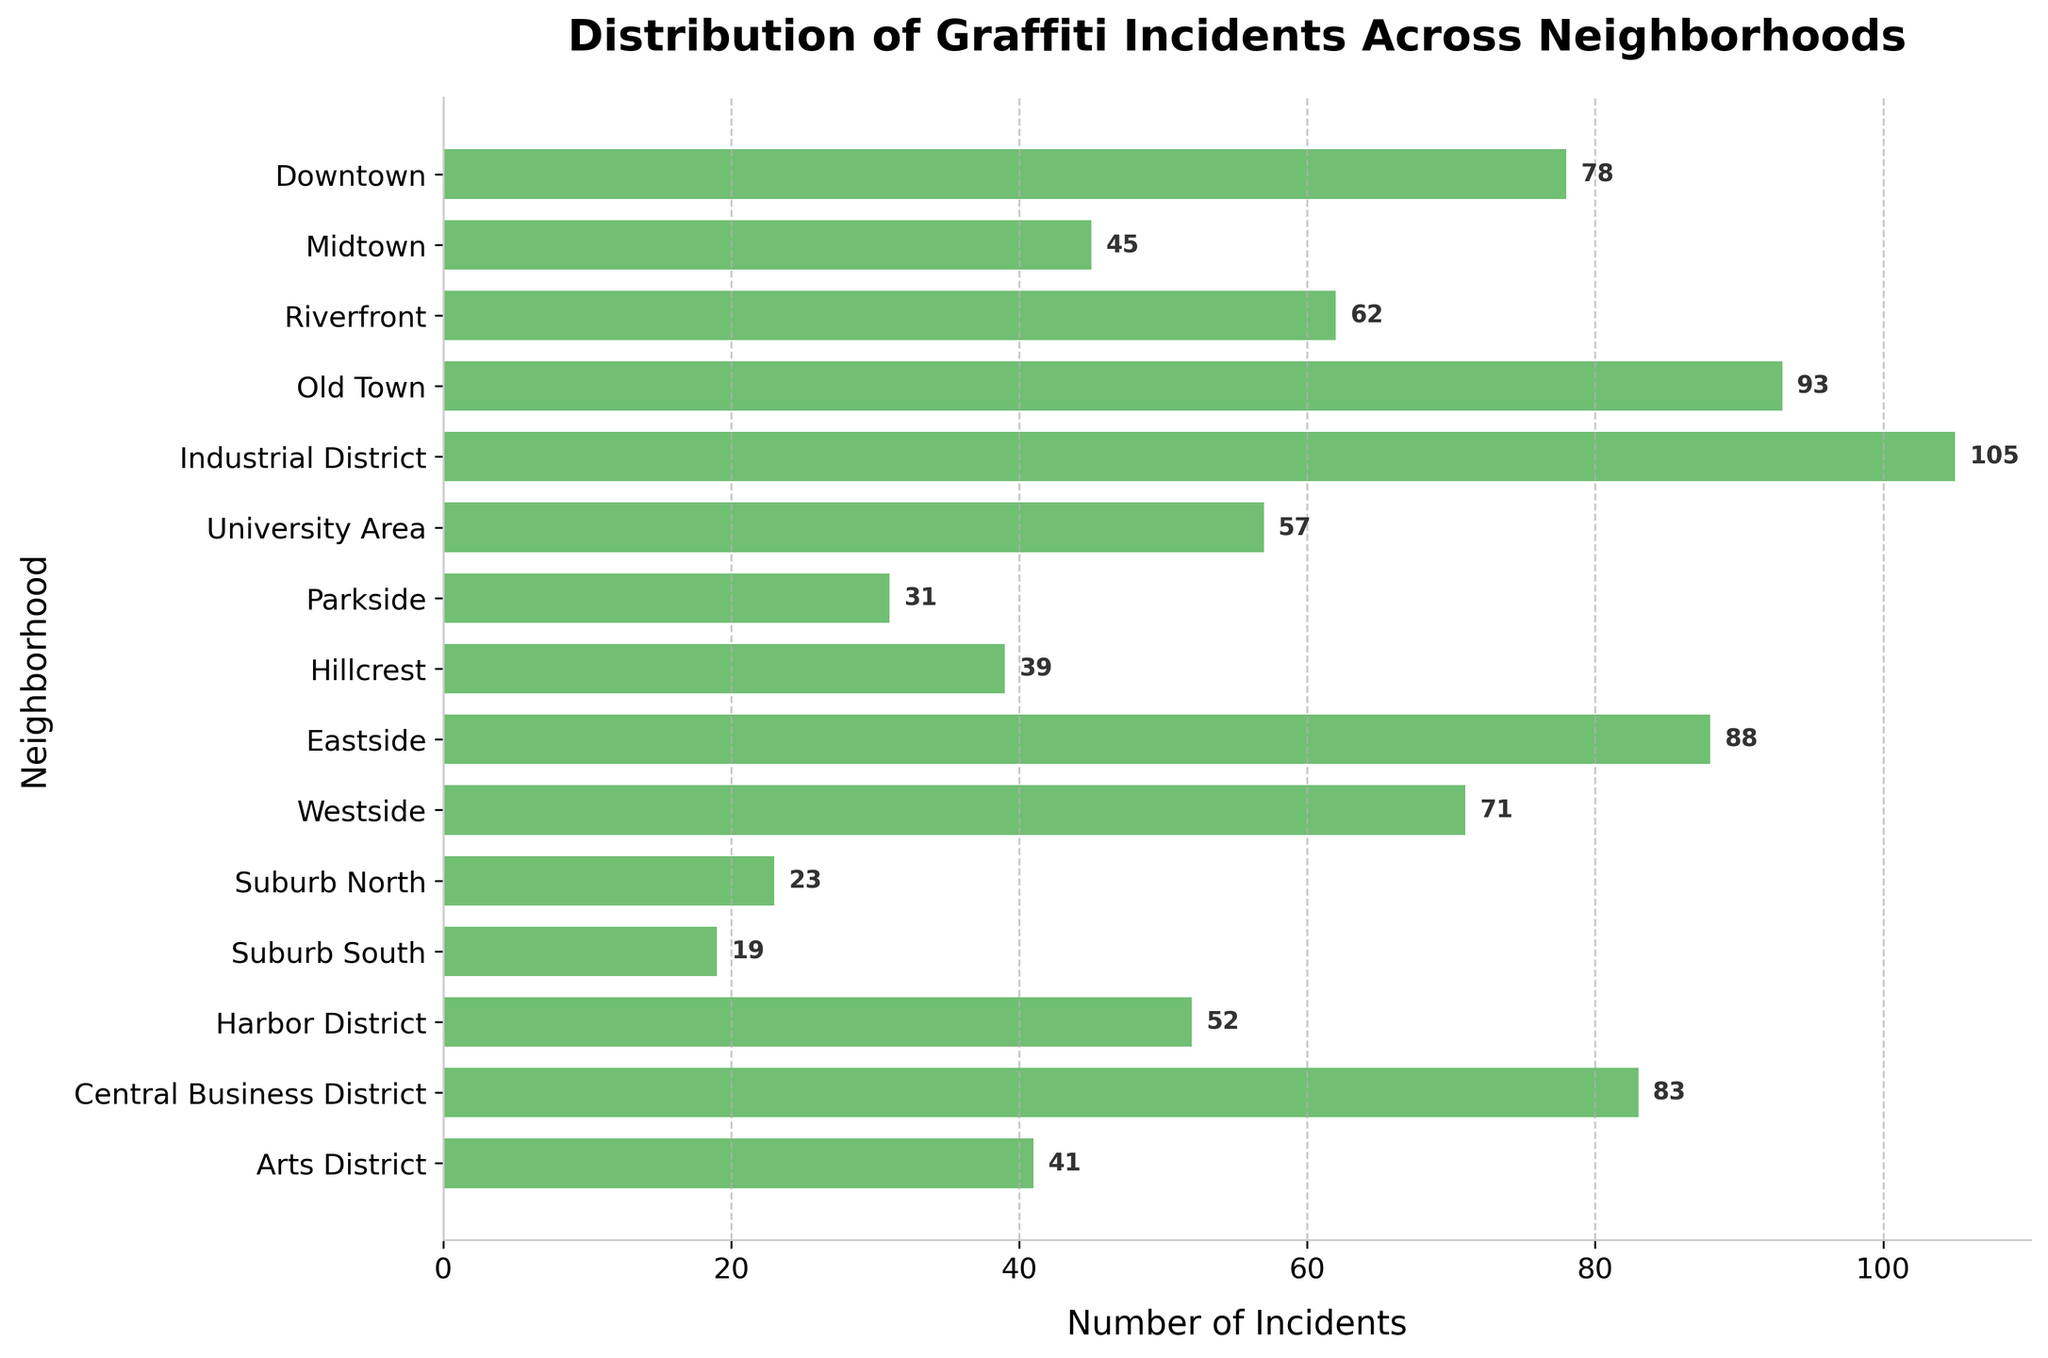What's the title of the figure? The title of the figure is located at the top center and usually is in bold font to indicate what the figure represents. It provides a concise description of the plotted data.
Answer: Distribution of Graffiti Incidents Across Neighborhoods How many neighborhoods are represented in the figure? The number of neighborhoods can be determined by counting the individual bars in the horizontal density plot. Each bar corresponds to a neighborhood.
Answer: 15 Which neighborhood has the highest number of graffiti incidents? By examining the horizontal length of the bars, the neighborhood with the longest bar represents the highest number of incidents. Here, the "Industrial District" bar is the longest.
Answer: Industrial District Which two neighborhoods have the closest number of graffiti incidents? Looking for bars with almost equal lengths on the horizontal axis, "Hillcrest" and "Arts District" have incidences very close to one another. This can be further confirmed by the numbers next to the bars.
Answer: Hillcrest and Arts District Which neighborhood has fewer graffiti incidents, Parkside or Suburb North? Compare the lengths of the bars for both neighborhoods, where a shorter bar indicates fewer incidents. Parkside has more incidents than Suburb North.
Answer: Suburb North Which neighborhood has the median number of graffiti incidents? Sort the neighborhoods by the number of incidents and find the middle value. The incidents in ascending order are: 19, 23, 31, 39, 41, 45, 52, 57, 62, 71, 78, 83, 88, 93, 105. The median is the 8th value.
Answer: 57 (University Area) Which neighborhoods have more than 80 graffiti incidents? Identify bars with values greater than 80. These neighborhoods are Industrial District, Old Town, Eastside, and Central Business District.
Answer: Industrial District, Old Town, Eastside, Central Business District 